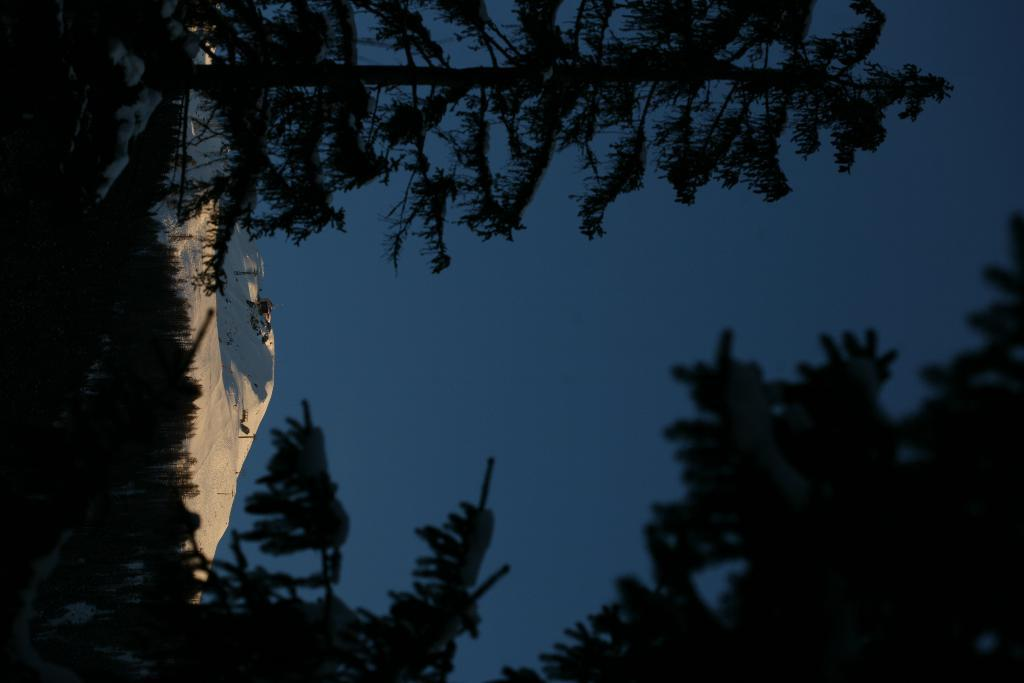What type of vegetation can be seen on the sides of the image? There are trees on the sides of the image. What part of the natural environment is visible in the image? The sky is visible in the image. What time of day might the image represent? The image appears to be taken at dawn time. Where is the lift located in the image? There is no lift present in the image. Can you see anyone giving a boot in the image? There is no boot or any related action depicted in the image. 